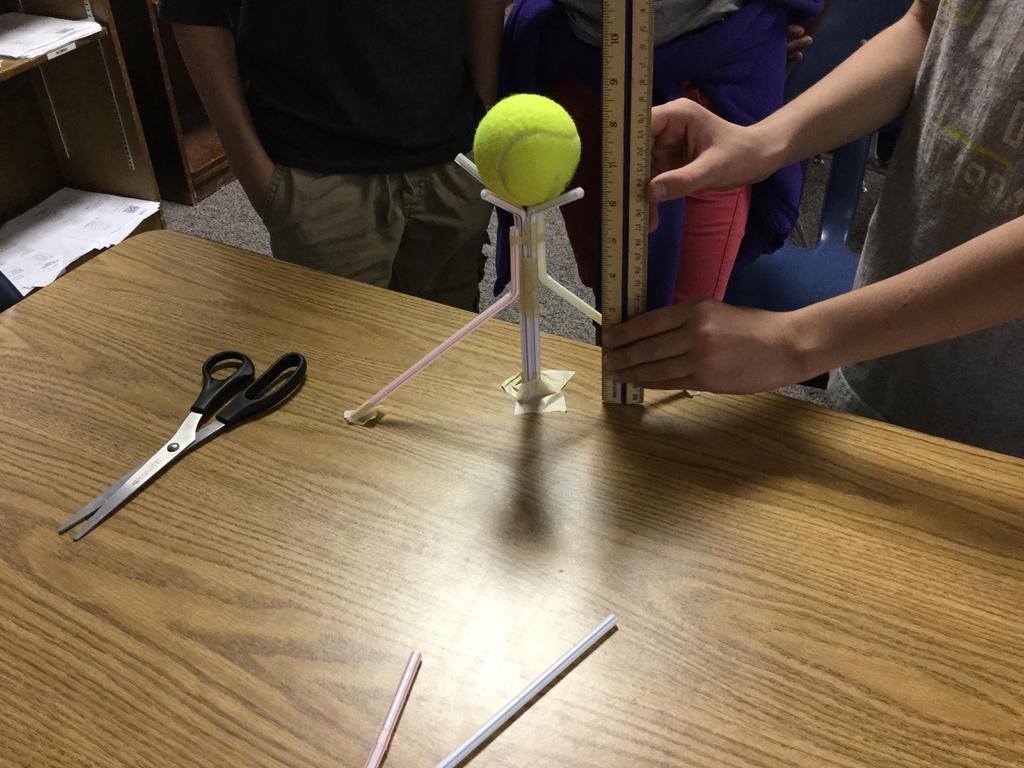How would you summarize this image in a sentence or two? In this picture there are group of boys, those who are experimenting with the help of scale and ball, there is a scissors on the table and there are book shelves at the left side of the image. 